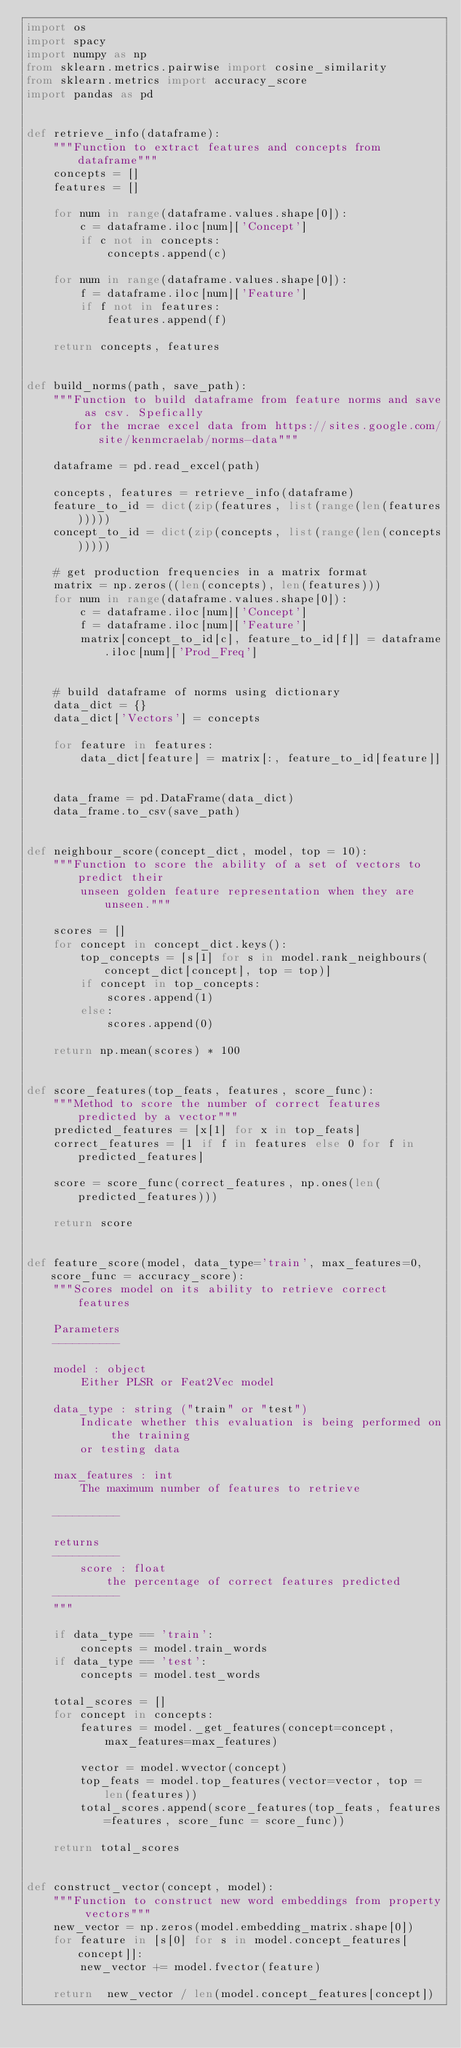Convert code to text. <code><loc_0><loc_0><loc_500><loc_500><_Python_>import os 
import spacy 
import numpy as np 
from sklearn.metrics.pairwise import cosine_similarity
from sklearn.metrics import accuracy_score
import pandas as pd 


def retrieve_info(dataframe):
    """Function to extract features and concepts from dataframe"""
    concepts = []
    features = []

    for num in range(dataframe.values.shape[0]):
        c = dataframe.iloc[num]['Concept']
        if c not in concepts:
            concepts.append(c)

    for num in range(dataframe.values.shape[0]):
        f = dataframe.iloc[num]['Feature']
        if f not in features:
            features.append(f)
            
    return concepts, features


def build_norms(path, save_path):
    """Function to build dataframe from feature norms and save as csv. Spefically 
       for the mcrae excel data from https://sites.google.com/site/kenmcraelab/norms-data"""
    
    dataframe = pd.read_excel(path)
    
    concepts, features = retrieve_info(dataframe)
    feature_to_id = dict(zip(features, list(range(len(features)))))
    concept_to_id = dict(zip(concepts, list(range(len(concepts)))))
    
    # get production frequencies in a matrix format
    matrix = np.zeros((len(concepts), len(features)))
    for num in range(dataframe.values.shape[0]):
        c = dataframe.iloc[num]['Concept']
        f = dataframe.iloc[num]['Feature']
        matrix[concept_to_id[c], feature_to_id[f]] = dataframe.iloc[num]['Prod_Freq']
    
    
    # build dataframe of norms using dictionary 
    data_dict = {}
    data_dict['Vectors'] = concepts

    for feature in features:
        data_dict[feature] = matrix[:, feature_to_id[feature]]
    
    
    data_frame = pd.DataFrame(data_dict)
    data_frame.to_csv(save_path)


def neighbour_score(concept_dict, model, top = 10):
    """Function to score the ability of a set of vectors to predict their 
        unseen golden feature representation when they are unseen."""
    
    scores = []
    for concept in concept_dict.keys():
        top_concepts = [s[1] for s in model.rank_neighbours(concept_dict[concept], top = top)]
        if concept in top_concepts:
            scores.append(1)
        else:
            scores.append(0)
            
    return np.mean(scores) * 100


def score_features(top_feats, features, score_func):
    """Method to score the number of correct features predicted by a vector"""
    predicted_features = [x[1] for x in top_feats]
    correct_features = [1 if f in features else 0 for f in predicted_features]
    
    score = score_func(correct_features, np.ones(len(predicted_features)))

    return score


def feature_score(model, data_type='train', max_features=0, score_func = accuracy_score):
    """Scores model on its ability to retrieve correct features

    Parameters
    ----------

    model : object 
        Either PLSR or Feat2Vec model 

    data_type : string ("train" or "test")
        Indicate whether this evaluation is being performed on the training 
        or testing data 

    max_features : int 
        The maximum number of features to retrieve

    ----------

    returns 
    ----------
        score : float
            the percentage of correct features predicted
    ----------
    """

    if data_type == 'train':
        concepts = model.train_words
    if data_type == 'test':
        concepts = model.test_words

    total_scores = []
    for concept in concepts:
        features = model._get_features(concept=concept, max_features=max_features)
        
        vector = model.wvector(concept)
        top_feats = model.top_features(vector=vector, top = len(features))
        total_scores.append(score_features(top_feats, features=features, score_func = score_func))

    return total_scores
    

def construct_vector(concept, model):
    """Function to construct new word embeddings from property vectors"""
    new_vector = np.zeros(model.embedding_matrix.shape[0])
    for feature in [s[0] for s in model.concept_features[concept]]:
        new_vector += model.fvector(feature)
        
    return  new_vector / len(model.concept_features[concept])

</code> 